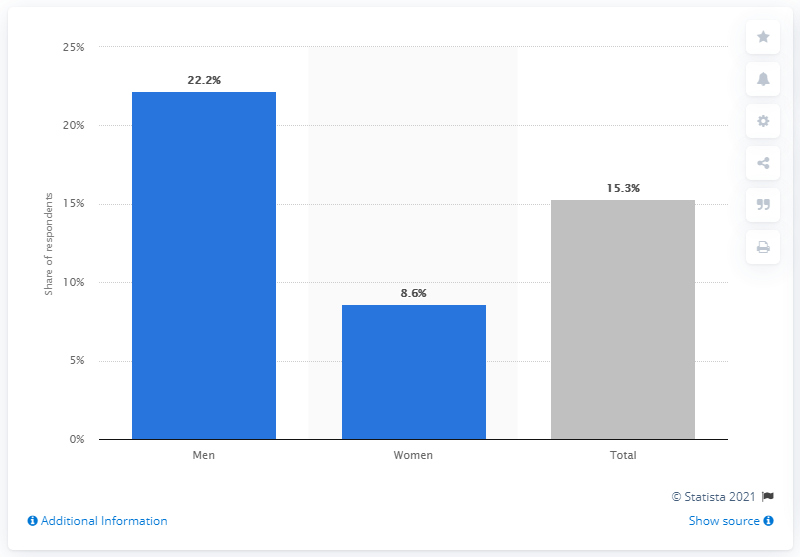What was the percentage of women who searched for sexual partners on the internet? According to the data presented in the chart, the percentage of women who searched for sexual partners on the internet is 8.6%. 